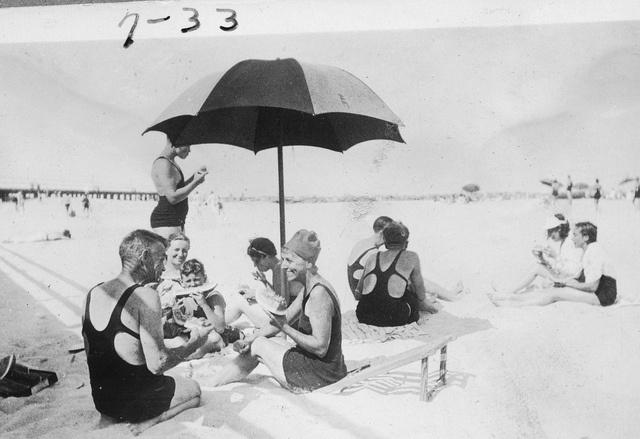Describe the objects in this image and their specific colors. I can see umbrella in gray, black, darkgray, and lightgray tones, people in gray, black, darkgray, and lightgray tones, people in gray, lightgray, darkgray, and black tones, people in gray, black, darkgray, and lightgray tones, and people in gray, lightgray, darkgray, and black tones in this image. 